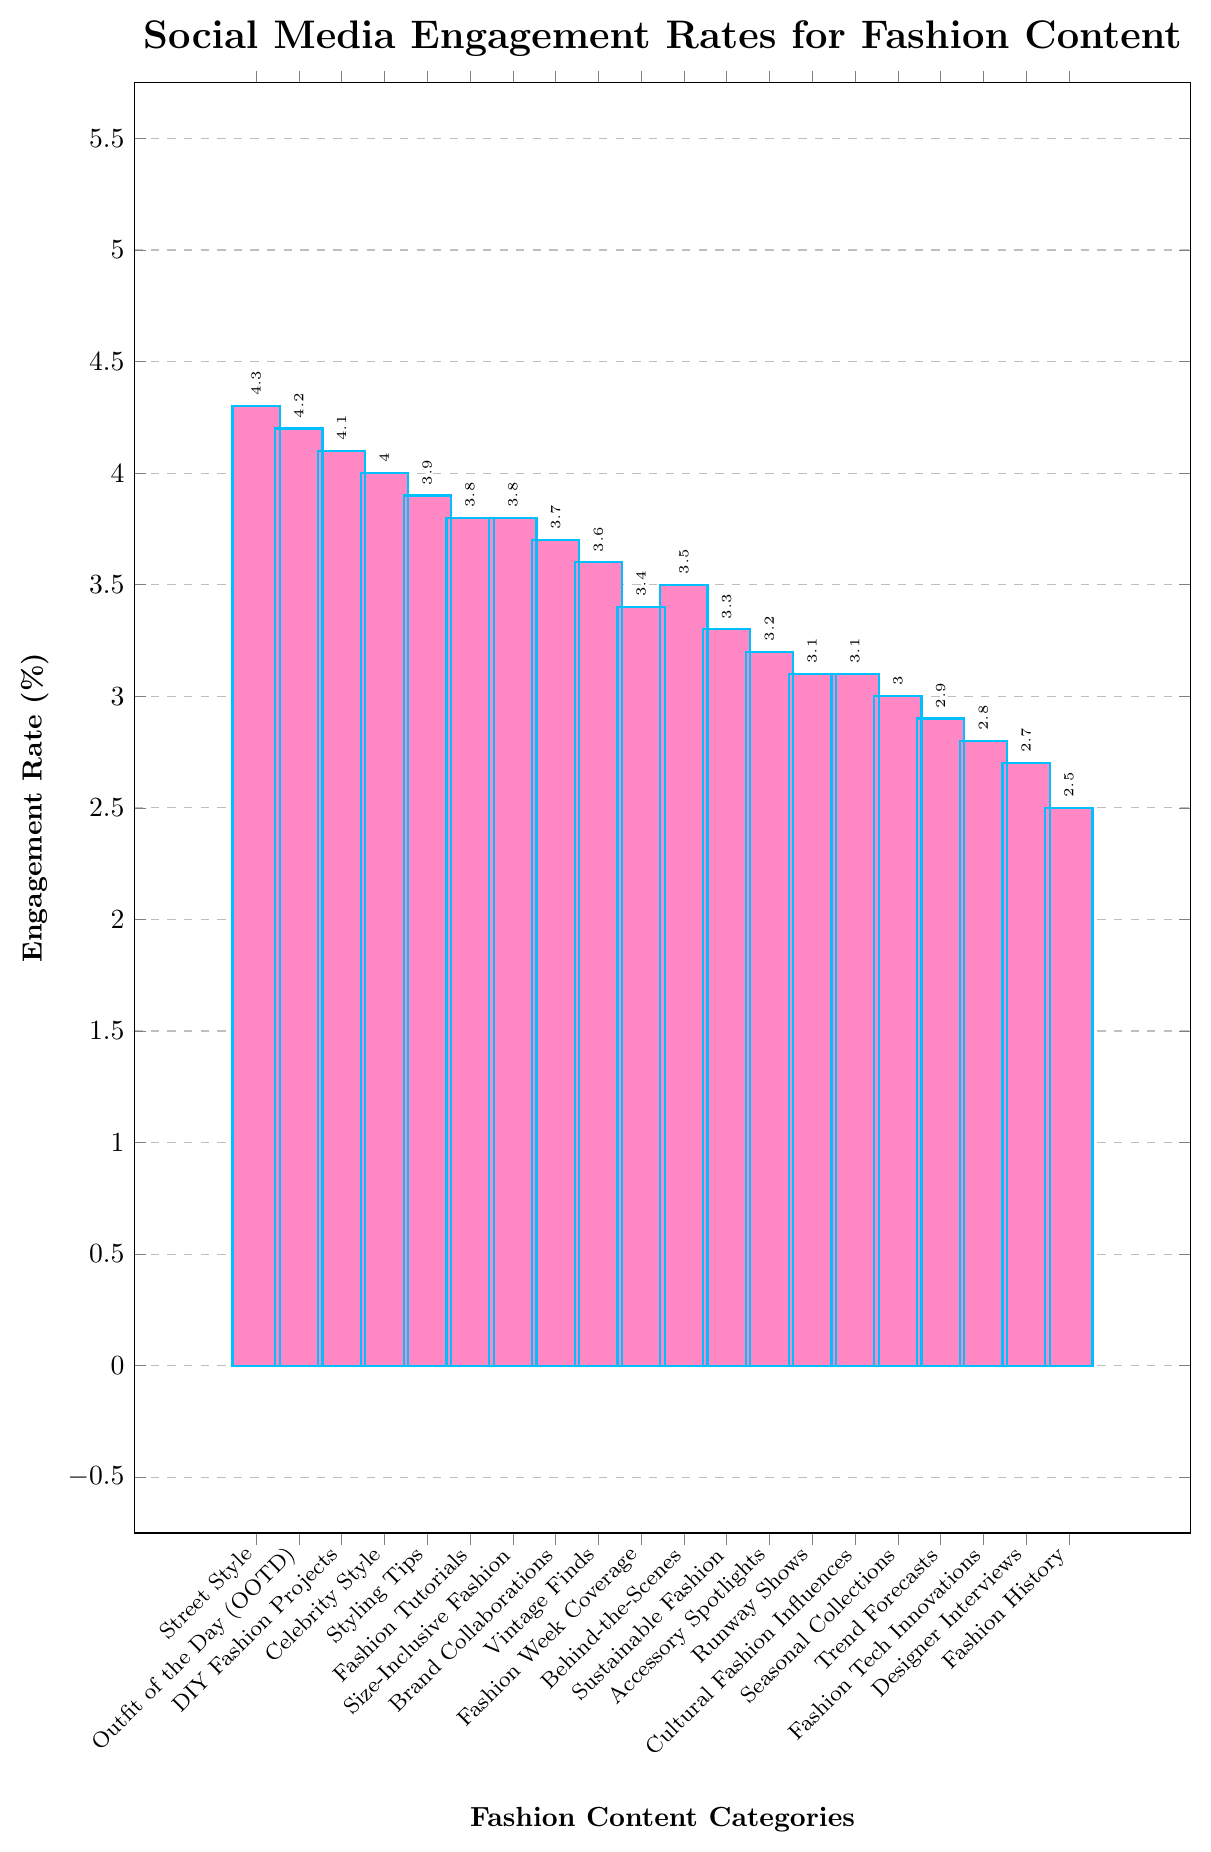What is the engagement rate for the "Street Style" category? To determine the engagement rate for "Street Style," look for the bar labeled "Street Style" on the x-axis and read the corresponding y-axis value, which the bar reaches.
Answer: 4.3 Which category has the lowest engagement rate? Identify the shortest bar in the chart and note the category it represents, which is labeled on the x-axis.
Answer: Fashion History How much higher is the engagement rate for "Outfit of the Day (OOTD)" compared to "Designer Interviews"? Subtract the engagement rate of "Designer Interviews" from the engagement rate of "Outfit of the Day (OOTD)": 4.2 - 2.7 = 1.5.
Answer: 1.5 Which categories have an engagement rate of 3.8% and higher? Scan the chart for all the bars that reach or exceed the 3.8% mark on the y-axis and note their categories labeled on the x-axis.
Answer: Street Style, Outfit of the Day (OOTD), DIY Fashion Projects, Celebrity Style, Styling Tips, Fashion Tutorials, Size-Inclusive Fashion What is the average engagement rate for "Sustainable Fashion," "Accessory Spotlights," and "Runway Shows"? Sum the engagement rates of the three categories and divide by the number of categories: (3.3 + 3.2 + 3.1) / 3 = 3.2.
Answer: 3.2 Which category has a higher engagement rate, "Vintage Finds" or "Brand Collaborations"? Compare the heights of the bars for "Vintage Finds" and "Brand Collaborations" and note which one reaches higher on the y-axis.
Answer: Vintage Finds What is the sum of the engagement rates of the top three categories with the highest engagement? Identify the three tallest bars and sum their engagement rates: 4.3 + 4.2 + 4.1 = 12.6.
Answer: 12.6 Which category has an engagement rate closest to the average engagement rate of all categories? Calculate the average of all engagement rates, then find the category with the engagement rate closest to this average. Calculation: (4.3 + 4.2 + 4.1 + 4.0 + 3.9 + 3.8 + 3.8 + 3.7 + 3.6 + 3.5 + 3.4 + 3.3 + 3.2 + 3.1 + 3.1 + 3.0 + 2.9 + 2.8 + 2.7 + 2.5) / 20 = 3.48. The closest value is 3.5 from Behind-the-Scenes.
Answer: Behind-the-Scenes 